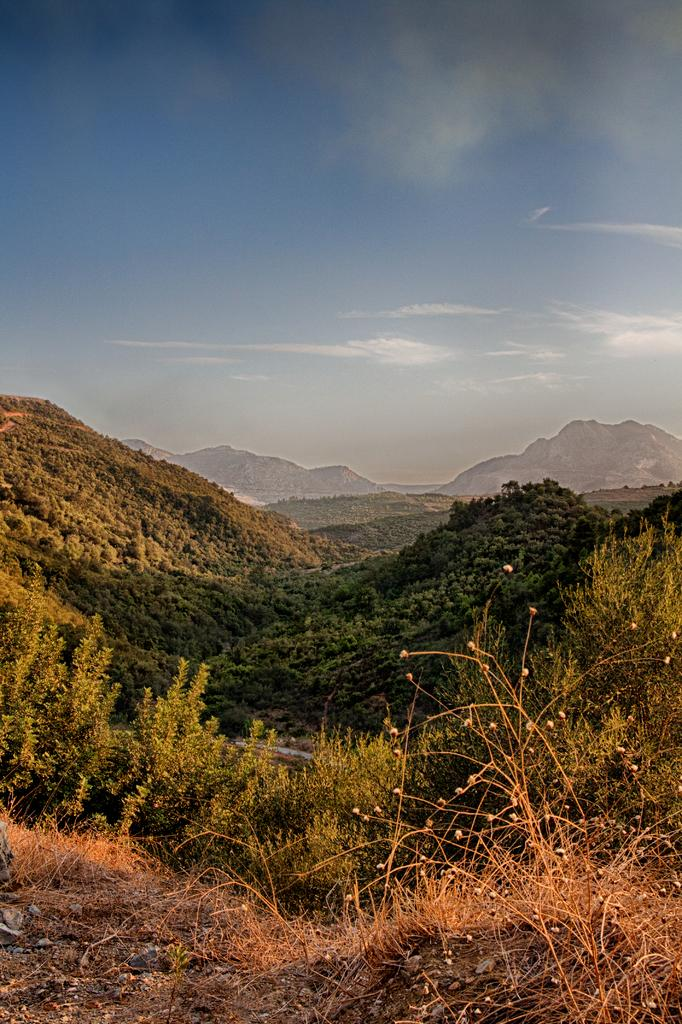What type of vegetation can be seen in the image? There is dried grass and plants in the image. How many trees are visible in the image? There are many trees in the image. What can be seen in the background of the image? There are mountains, clouds, and the sky visible in the background of the image. What is the rate of harmony between the apple and the trees in the image? There is no apple present in the image, so it is not possible to determine the rate of harmony between the apple and the trees. 